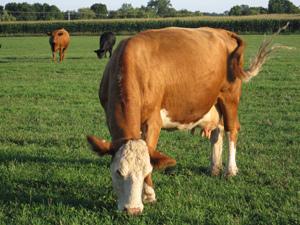Is this cow pregnant?
Be succinct. Yes. Are there any calves in this group of cows?
Give a very brief answer. No. Where is the udder?
Keep it brief. Under. What is it called when cows eat grass in this way?
Be succinct. Grazing. 